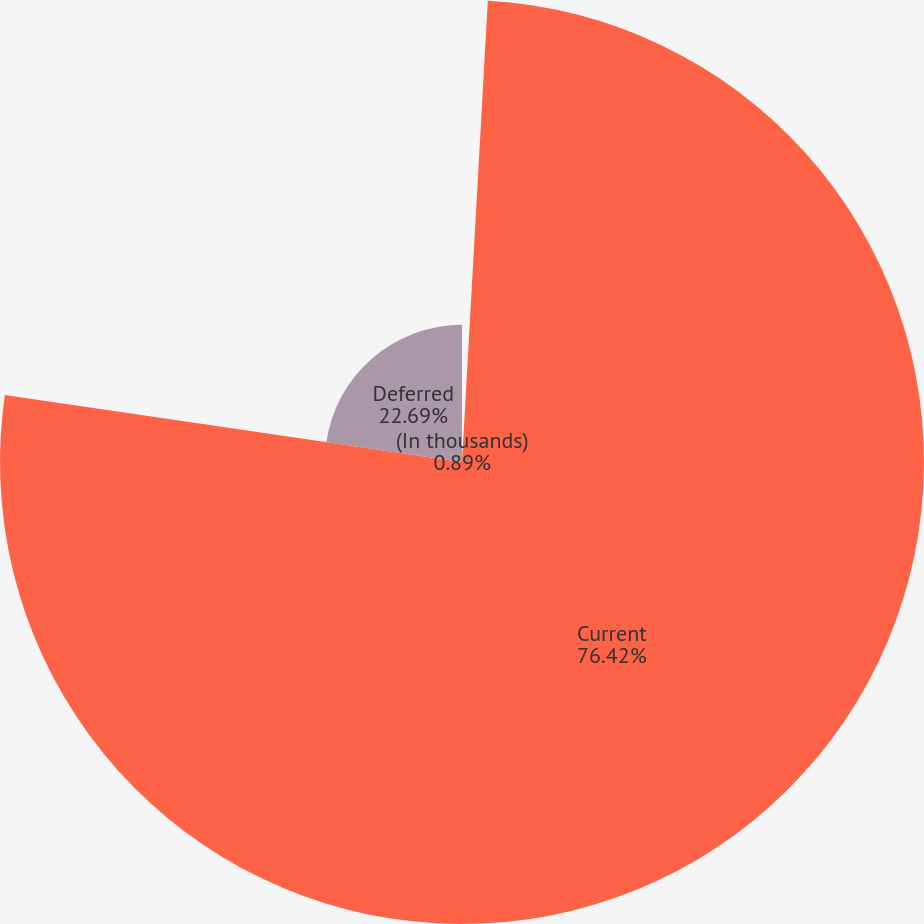Convert chart to OTSL. <chart><loc_0><loc_0><loc_500><loc_500><pie_chart><fcel>(In thousands)<fcel>Current<fcel>Deferred<nl><fcel>0.89%<fcel>76.43%<fcel>22.69%<nl></chart> 